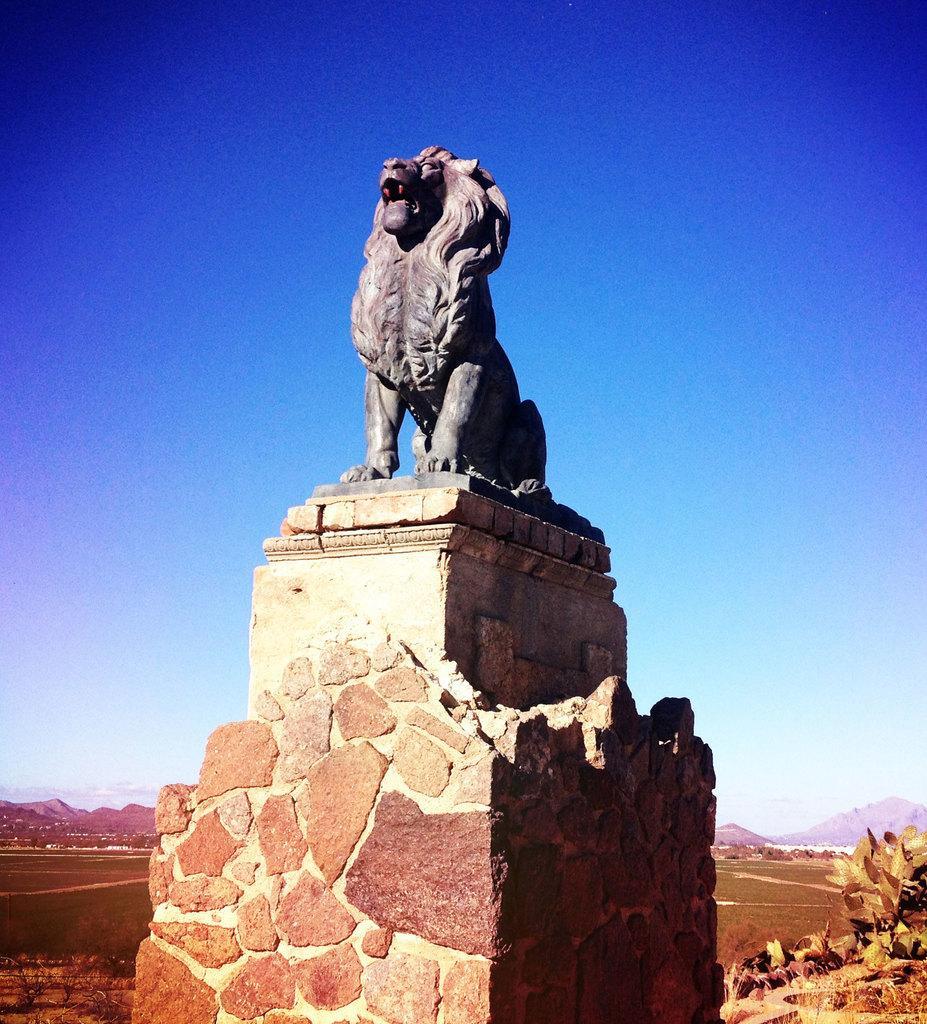Can you describe this image briefly? In the center of the image we can see a solid structure. On the solid structure, we can see one statue. In the background, we can see the sky, hills, plants and grass. 